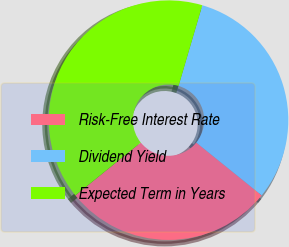Convert chart to OTSL. <chart><loc_0><loc_0><loc_500><loc_500><pie_chart><fcel>Risk-Free Interest Rate<fcel>Dividend Yield<fcel>Expected Term in Years<nl><fcel>28.37%<fcel>31.26%<fcel>40.37%<nl></chart> 